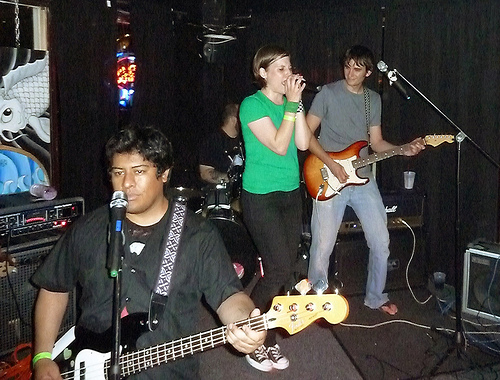<image>
Can you confirm if the guitar is in front of the microphone? No. The guitar is not in front of the microphone. The spatial positioning shows a different relationship between these objects. 